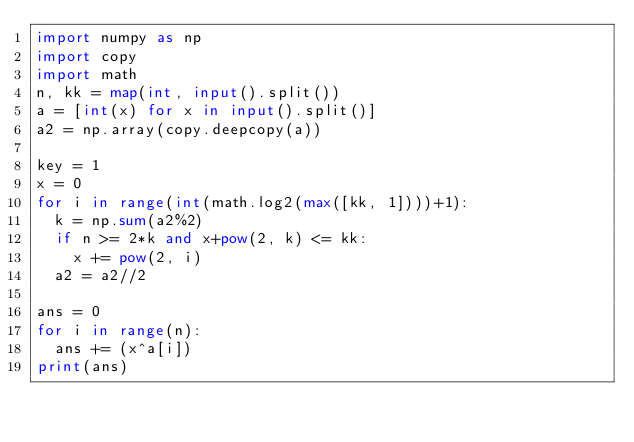Convert code to text. <code><loc_0><loc_0><loc_500><loc_500><_Python_>import numpy as np
import copy
import math
n, kk = map(int, input().split())
a = [int(x) for x in input().split()]
a2 = np.array(copy.deepcopy(a))

key = 1
x = 0
for i in range(int(math.log2(max([kk, 1])))+1):
  k = np.sum(a2%2)
  if n >= 2*k and x+pow(2, k) <= kk:
    x += pow(2, i)
  a2 = a2//2

ans = 0
for i in range(n):
  ans += (x^a[i])
print(ans)</code> 